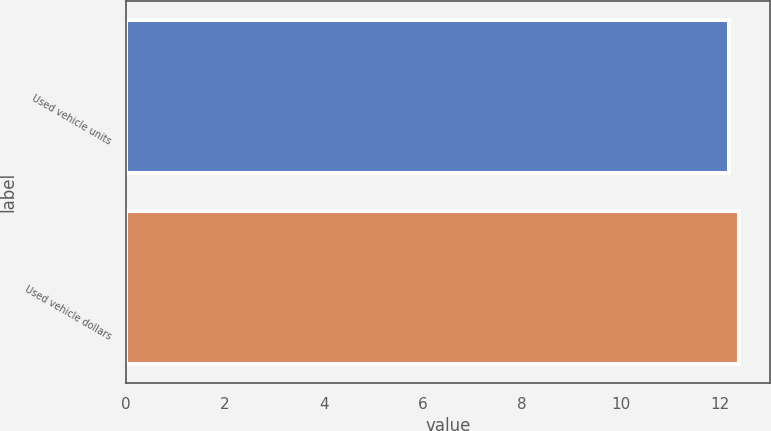Convert chart to OTSL. <chart><loc_0><loc_0><loc_500><loc_500><bar_chart><fcel>Used vehicle units<fcel>Used vehicle dollars<nl><fcel>12.2<fcel>12.4<nl></chart> 